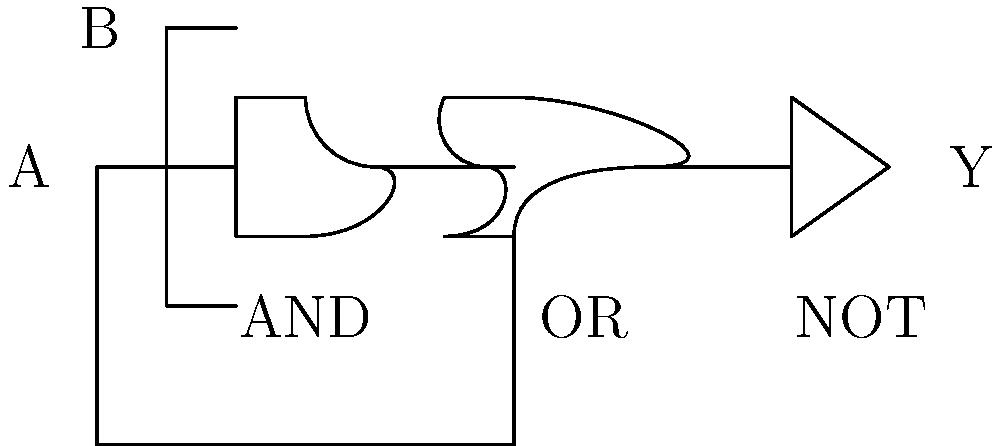In the context of logical reasoning and narrative structure in the Ramayana, consider the following logic circuit. If we interpret input A as "Rama's exile" and input B as "Sita's abduction," what might the output Y represent in terms of the epic's plot development? Provide the truth table for this circuit and explain its significance in relation to the story's progression. To answer this question, let's approach it step-by-step:

1. First, we need to understand the logic circuit:
   - It consists of an AND gate, followed by an OR gate, and finally a NOT gate.
   - Input A goes to both the AND gate and the OR gate.
   - Input B goes only to the AND gate.

2. Let's create the truth table for this circuit:

   | A | B | AND | OR | NOT (Y) |
   |---|---|-----|----|----|
   | 0 | 0 |  0  | 0  |  1  |
   | 0 | 1 |  0  | 0  |  1  |
   | 1 | 0 |  0  | 1  |  0  |
   | 1 | 1 |  1  | 1  |  0  |

3. Interpreting the inputs and output in the context of the Ramayana:
   - A (Rama's exile): 0 = not exiled, 1 = exiled
   - B (Sita's abduction): 0 = not abducted, 1 = abducted
   - Y could represent "peace in the kingdom"

4. Analyzing the truth table in terms of the epic's plot:
   - When neither event occurs (0,0), there is peace (Y=1).
   - When only Sita is abducted (0,1), it's not historically accurate, but would still result in peace as Rama isn't exiled to act.
   - When Rama is exiled, regardless of Sita's state (1,0 or 1,1), there is no peace (Y=0).

5. The significance in the story's progression:
   - This circuit emphasizes that Rama's exile is the critical event that disrupts peace.
   - It shows that both events together (exile and abduction) create the most tumultuous situation, mirroring the epic's central conflict.
   - The use of the NOT gate at the end suggests that the presence of these events negates peace, which aligns with the narrative structure of the Ramayana.

This logical representation offers a unique perspective on the cause-and-effect relationship in the Ramayana's plot, highlighting how key events trigger the main conflicts and drive the story forward.
Answer: Peace in the kingdom, disrupted by Rama's exile 